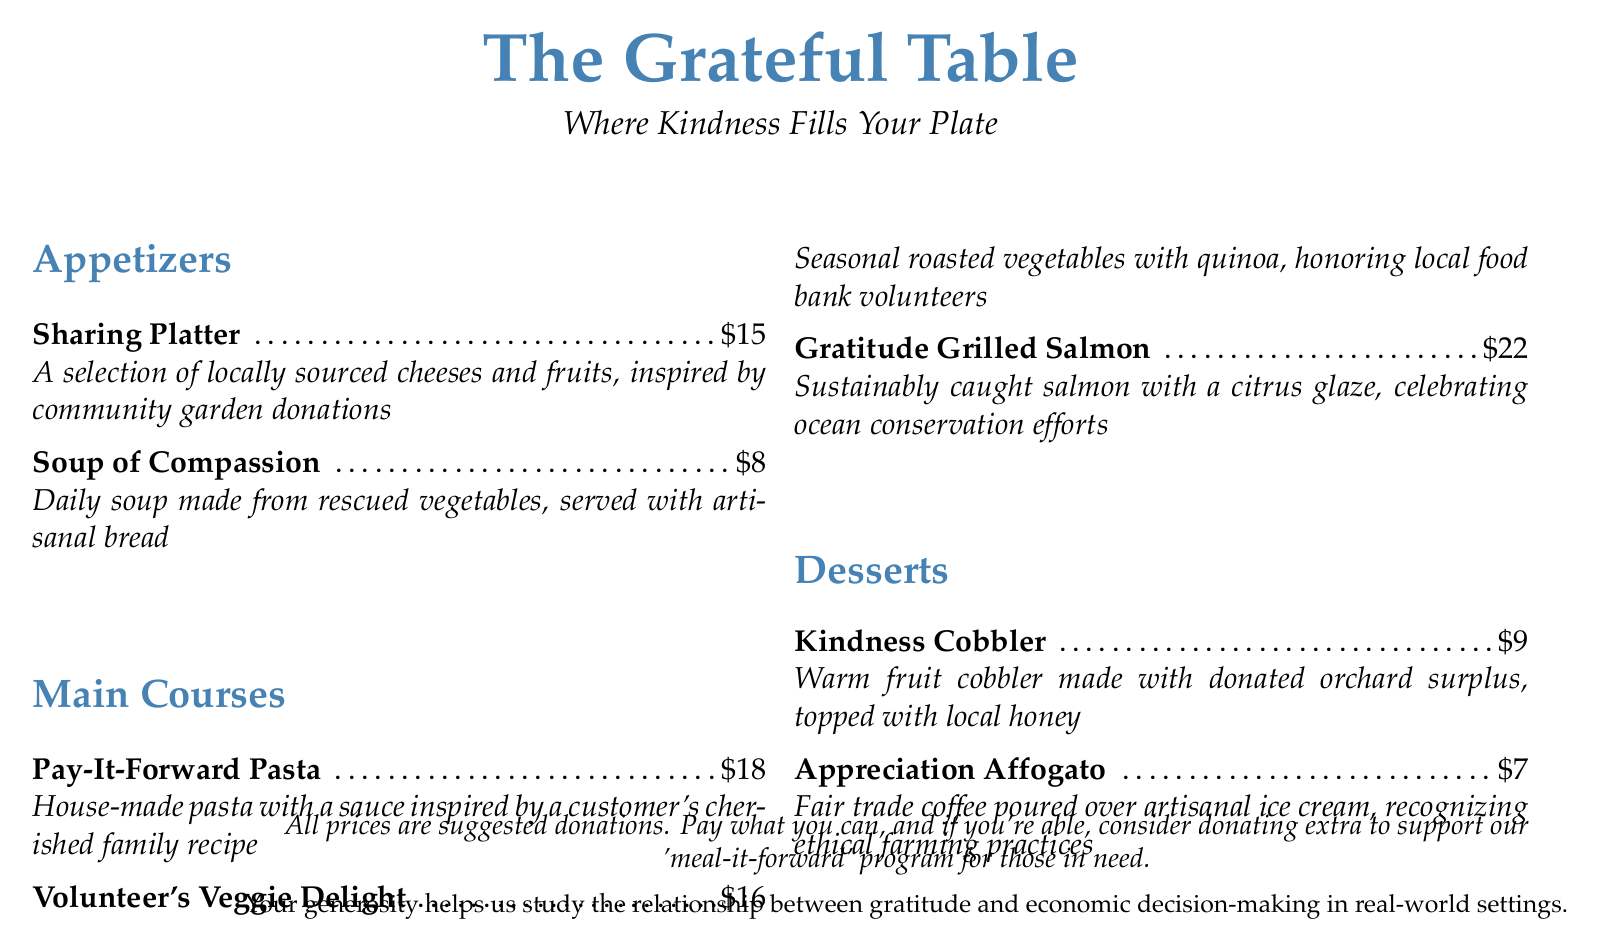What is the name of the restaurant? The restaurant's name is prominently displayed at the top of the document.
Answer: The Grateful Table What is the price of the Soup of Compassion? The price is listed next to the item description in the menu.
Answer: $8 What dish celebrates ocean conservation efforts? This requires knowing which dish has a description related to ocean conservation.
Answer: Gratitude Grilled Salmon What inspired the Sharing Platter? This question seeks to understand the specific inspiration behind one of the appetizers on the menu.
Answer: Community garden donations How much is suggested for the Pay-It-Forward Pasta? The amount is stated directly in the menu as a suggested donation.
Answer: $18 What type of coffee is used in the Appreciation Affogato? This requires identifying the coffee type mentioned in the dessert description.
Answer: Fair trade coffee What is a key aspect of the restaurant's pricing model? This question addresses the overall pricing philosophy mentioned in the document.
Answer: Suggested donations Which item is made with donated orchard surplus? This asks for the specific dessert that incorporates donated ingredients.
Answer: Kindness Cobbler What is the honor given by the Volunteer's Veggie Delight? The dish description indicates whom or what it honors.
Answer: Local food bank volunteers 